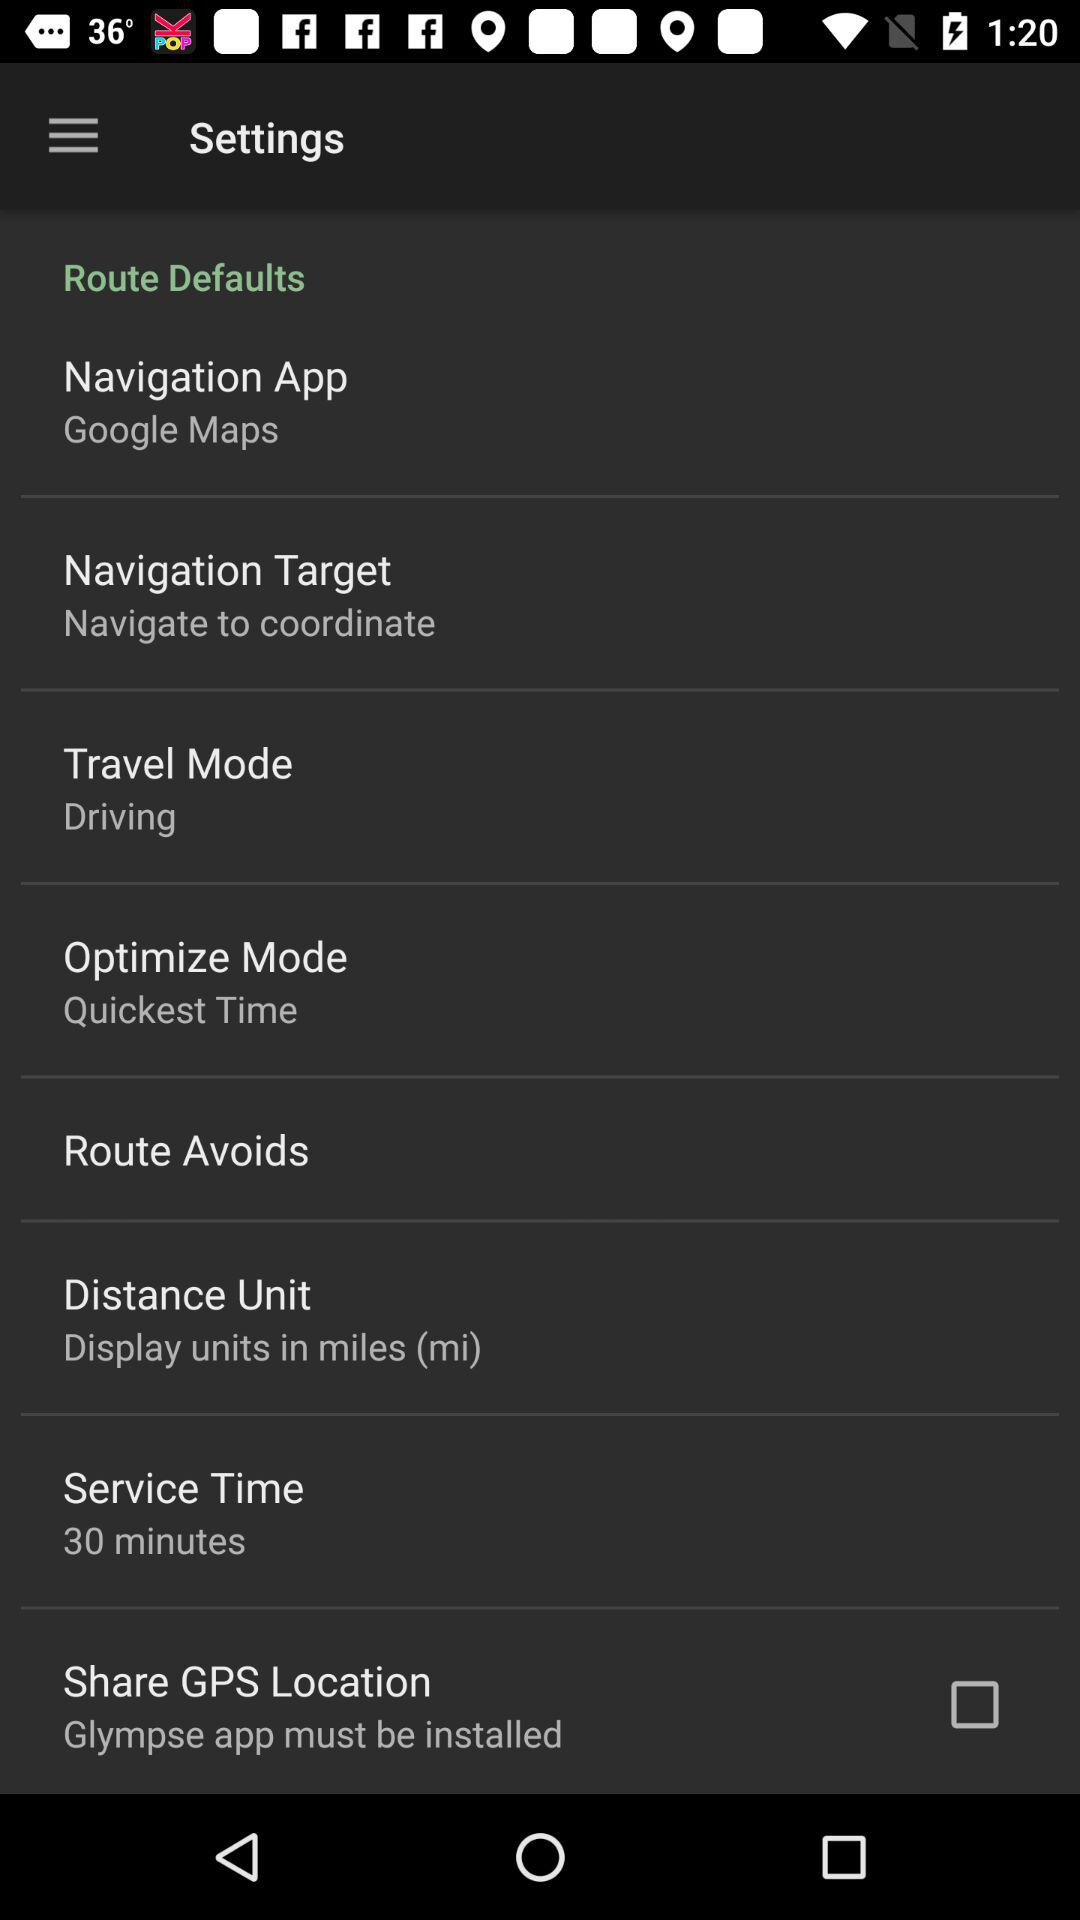What navigation app is selected? The selected navigation app is "Google Maps". 